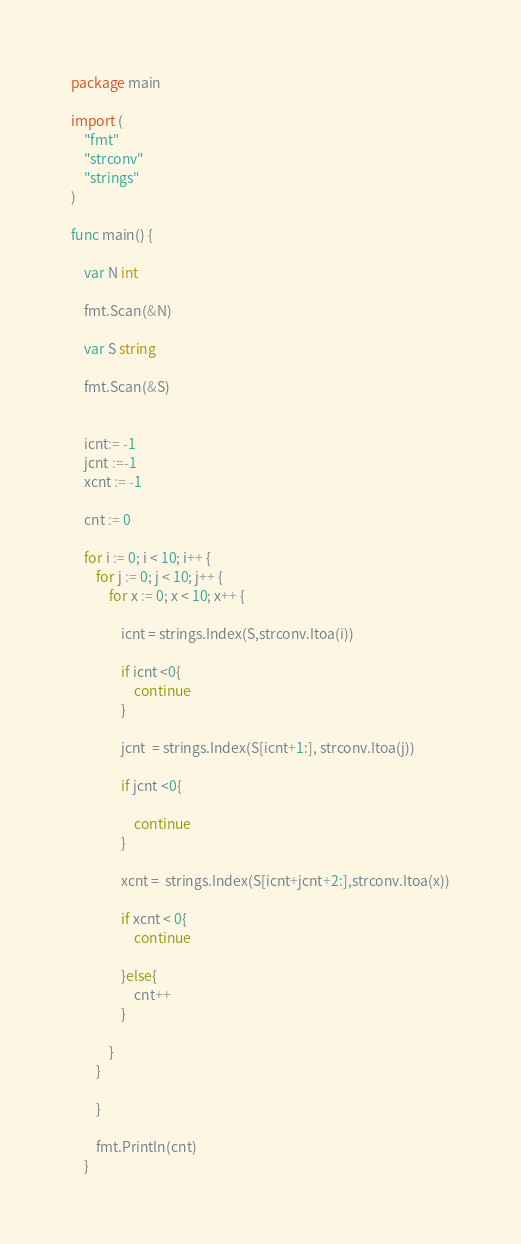<code> <loc_0><loc_0><loc_500><loc_500><_Go_>package main

import (
	"fmt"
	"strconv"
	"strings"
)

func main() {

	var N int

	fmt.Scan(&N)

	var S string

	fmt.Scan(&S)


	icnt:= -1 
	jcnt :=-1
	xcnt := -1

	cnt := 0

	for i := 0; i < 10; i++ {
		for j := 0; j < 10; j++ {
			for x := 0; x < 10; x++ {

				icnt = strings.Index(S,strconv.Itoa(i))

				if icnt <0{
					continue
				}

				jcnt  = strings.Index(S[icnt+1:], strconv.Itoa(j))

				if jcnt <0{

					continue
				}

				xcnt =  strings.Index(S[icnt+jcnt+2:],strconv.Itoa(x))

				if xcnt < 0{
					continue

				}else{
					cnt++
				}

			}
		}

		}

		fmt.Println(cnt)
	}</code> 